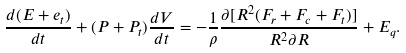Convert formula to latex. <formula><loc_0><loc_0><loc_500><loc_500>\frac { d ( E + e _ { t } ) } { d t } + ( P + P _ { t } ) \frac { d V } { d t } = - \frac { 1 } { \rho } \frac { \partial [ R ^ { 2 } ( F _ { r } + F _ { c } + F _ { t } ) ] } { R ^ { 2 } \partial R } + E _ { q } .</formula> 